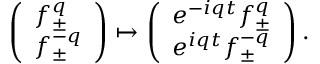Convert formula to latex. <formula><loc_0><loc_0><loc_500><loc_500>\left ( \begin{array} { l } { { f _ { \pm } ^ { q } } } \\ { { f _ { \pm } ^ { - q } } } \end{array} \right ) \mapsto \left ( \begin{array} { l } { { e ^ { - i q t } f _ { \pm } ^ { q } } } \\ { { e ^ { i q t } f _ { \pm } ^ { - q } } } \end{array} \right ) .</formula> 